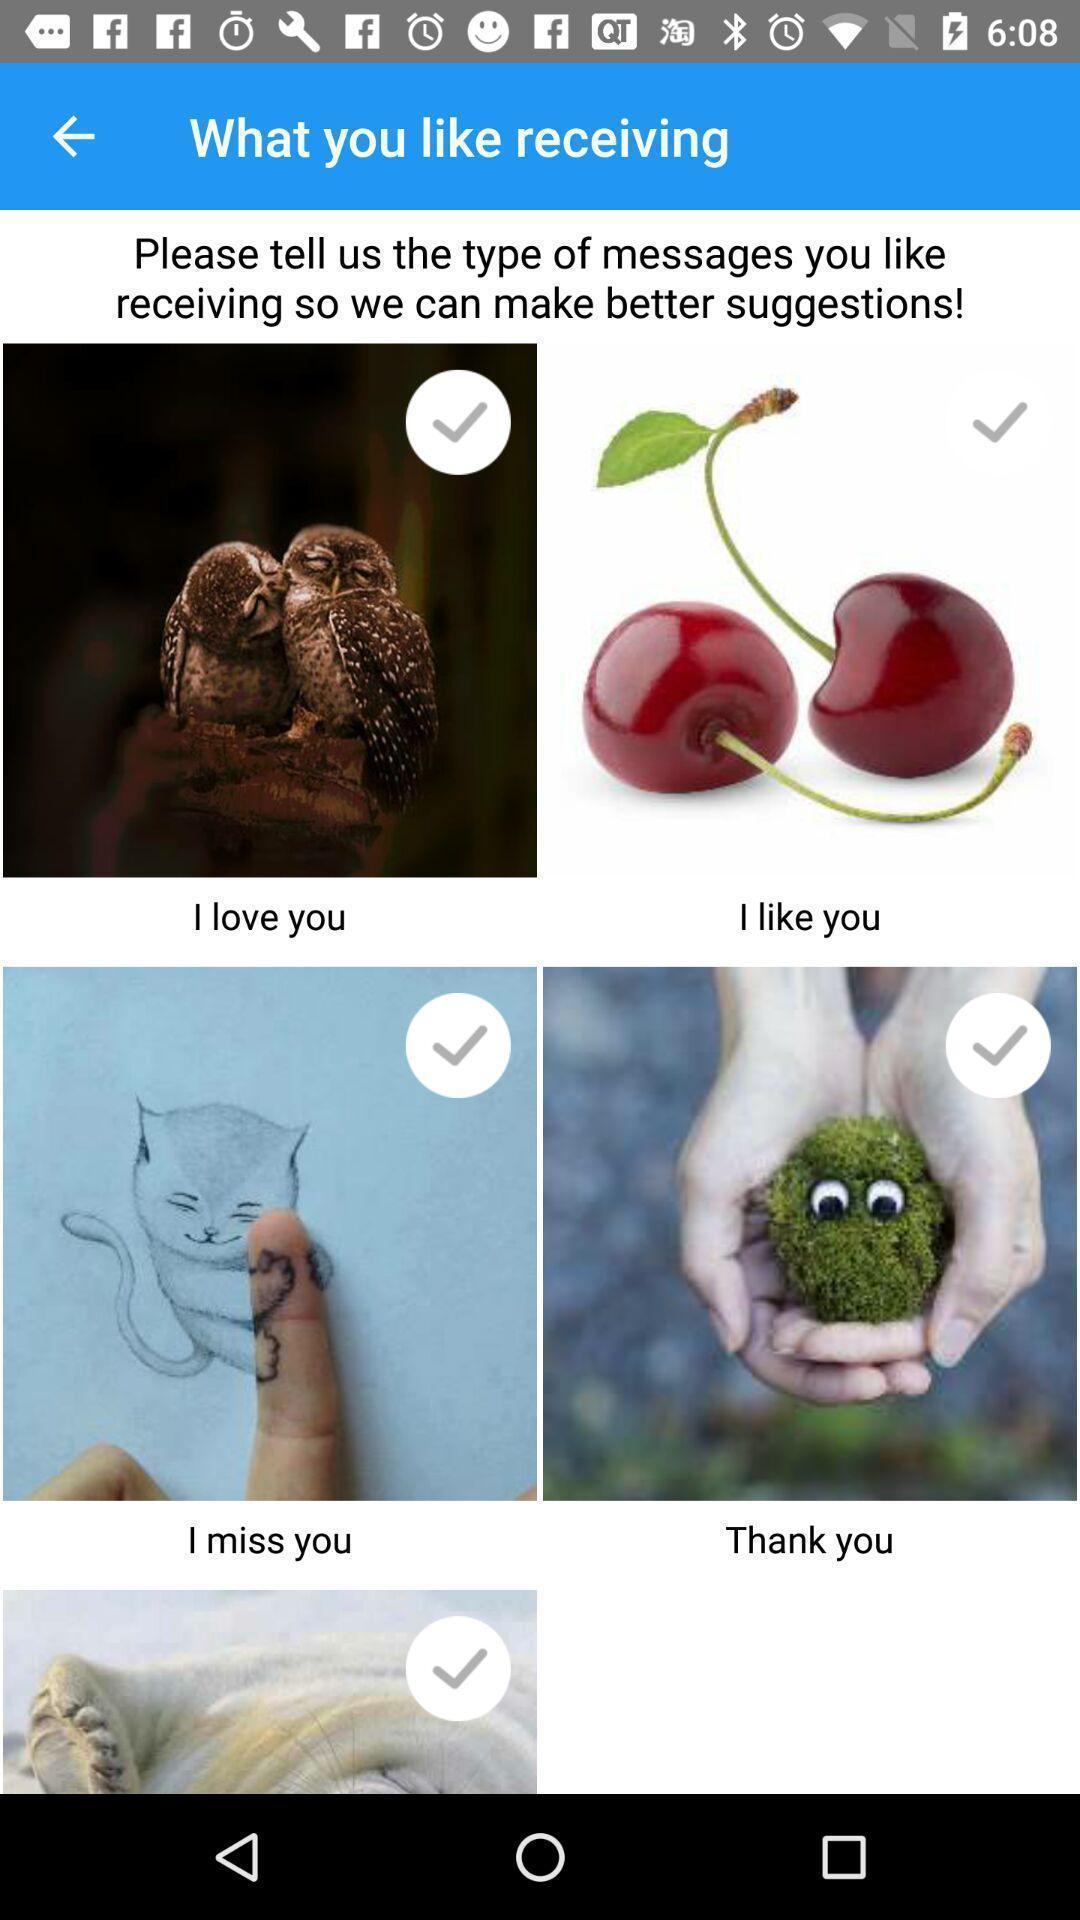Give me a summary of this screen capture. Stickers and emojis for a chatting app. 